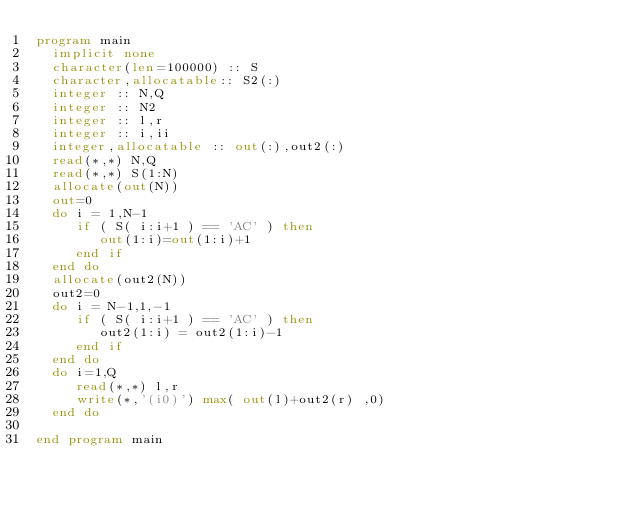Convert code to text. <code><loc_0><loc_0><loc_500><loc_500><_FORTRAN_>program main
  implicit none
  character(len=100000) :: S
  character,allocatable:: S2(:)
  integer :: N,Q
  integer :: N2
  integer :: l,r
  integer :: i,ii
  integer,allocatable :: out(:),out2(:)
  read(*,*) N,Q
  read(*,*) S(1:N)
  allocate(out(N))
  out=0
  do i = 1,N-1
     if ( S( i:i+1 ) == 'AC' ) then
        out(1:i)=out(1:i)+1
     end if
  end do
  allocate(out2(N))
  out2=0
  do i = N-1,1,-1
     if ( S( i:i+1 ) == 'AC' ) then
        out2(1:i) = out2(1:i)-1
     end if
  end do
  do i=1,Q
     read(*,*) l,r
     write(*,'(i0)') max( out(l)+out2(r) ,0)
  end do

end program main
</code> 